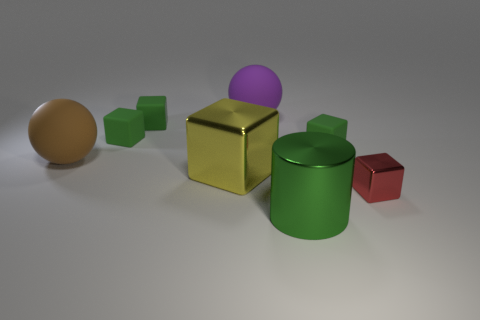Subtract all matte cubes. How many cubes are left? 2 Add 1 large blue objects. How many objects exist? 9 Subtract all yellow blocks. How many blocks are left? 4 Subtract 0 purple blocks. How many objects are left? 8 Subtract all cylinders. How many objects are left? 7 Subtract 1 cylinders. How many cylinders are left? 0 Subtract all purple cylinders. Subtract all brown balls. How many cylinders are left? 1 Subtract all brown cylinders. How many purple spheres are left? 1 Subtract all yellow cubes. Subtract all tiny shiny things. How many objects are left? 6 Add 3 big green objects. How many big green objects are left? 4 